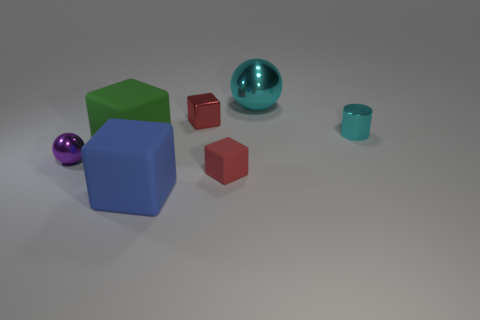Subtract 2 blocks. How many blocks are left? 2 Subtract all gray cylinders. How many red blocks are left? 2 Subtract all big blue cubes. How many cubes are left? 3 Add 3 large blue objects. How many objects exist? 10 Subtract all blue cubes. How many cubes are left? 3 Subtract all yellow cubes. Subtract all brown cylinders. How many cubes are left? 4 Subtract all cylinders. How many objects are left? 6 Add 5 tiny metal balls. How many tiny metal balls exist? 6 Subtract 0 green spheres. How many objects are left? 7 Subtract all big rubber things. Subtract all large cubes. How many objects are left? 3 